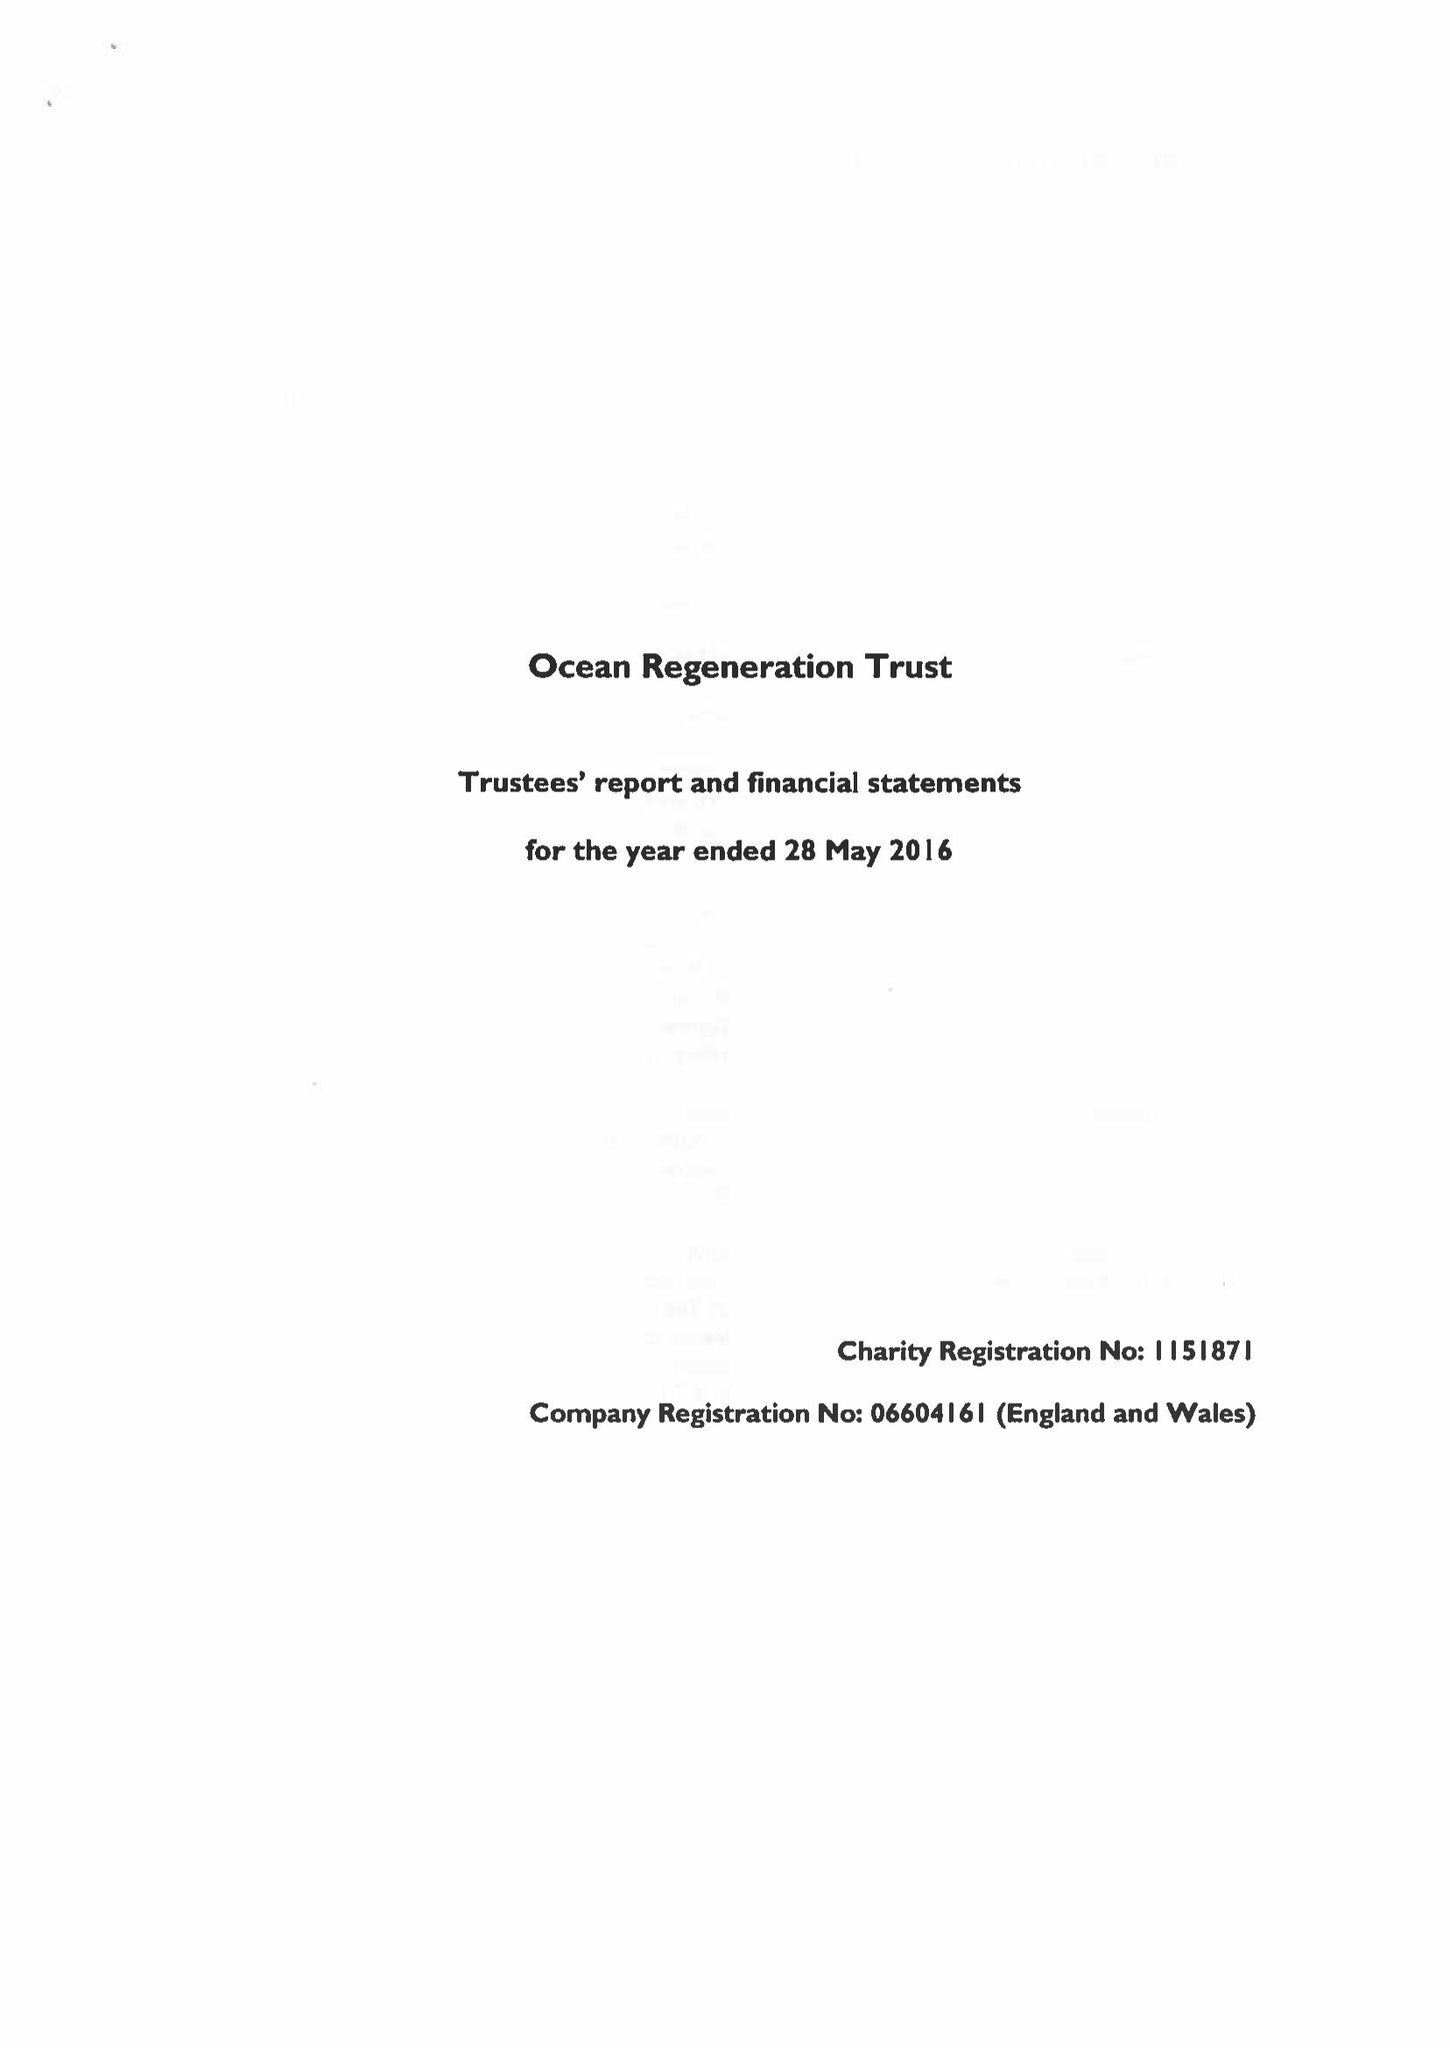What is the value for the charity_name?
Answer the question using a single word or phrase. Ocean Regeneration Trust 